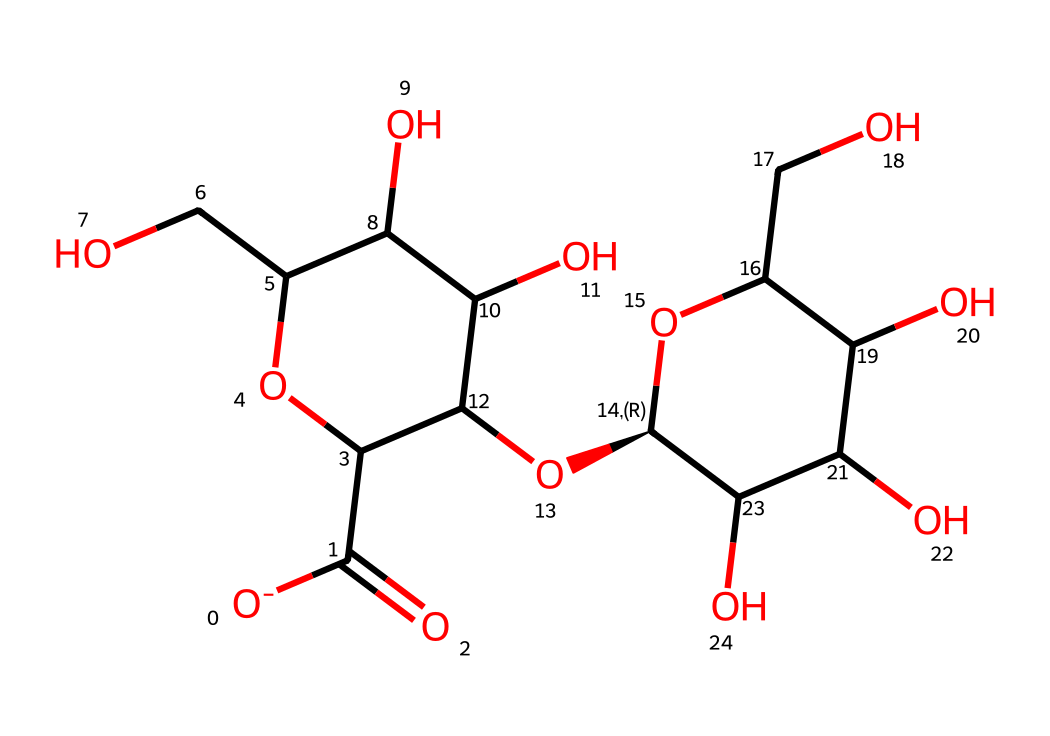How many carbon atoms are in the structure? To find the number of carbon atoms, we can analyze the chemical structure. Each carbon atom is typically represented by a 'C' in the SMILES notation. By counting the 'C' characters, we find there are 12 carbon atoms.
Answer: 12 What functional groups are present in cellulose? Functional groups can be identified by looking for specific atoms and their combinations, such as hydroxyl (-OH) groups or carbonyl (C=O) groups. In this structure, we can identify multiple hydroxyl groups by the presence of 'O' followed by 'C,' indicating many -OH groups.
Answer: hydroxyl Is cellulose a monomer or polymer? Cellulose is a polymer made of multiple repeating units. In its structure, we can see that it consists of long chains made up of monosaccharide units (glucose), indicating it is a polymer.
Answer: polymer How many oxygen atoms are in the structure? Similar to counting carbon atoms, we can count the number of oxygen atoms represented by 'O' in the SMILES notation. By examining the structure, we find there are 6 oxygen atoms present in the cellulose molecule.
Answer: 6 What sugar unit is cellulose primarily composed of? Cellulose is primarily composed of glucose units, which can be recognized by the repeating structure seen in the chemical representation. Each repeating unit contains a specific arrangement of carbon, hydrogen, and oxygen typical of glucose.
Answer: glucose What type of glycosidic bond is formed in cellulose? In cellulose, the glycosidic bonds formed are β(1→4) linkages between the glucose units. This can be reasoned from the way the glucose units are linked together in this structure, which can slide into their respective positions.
Answer: β(1→4) 